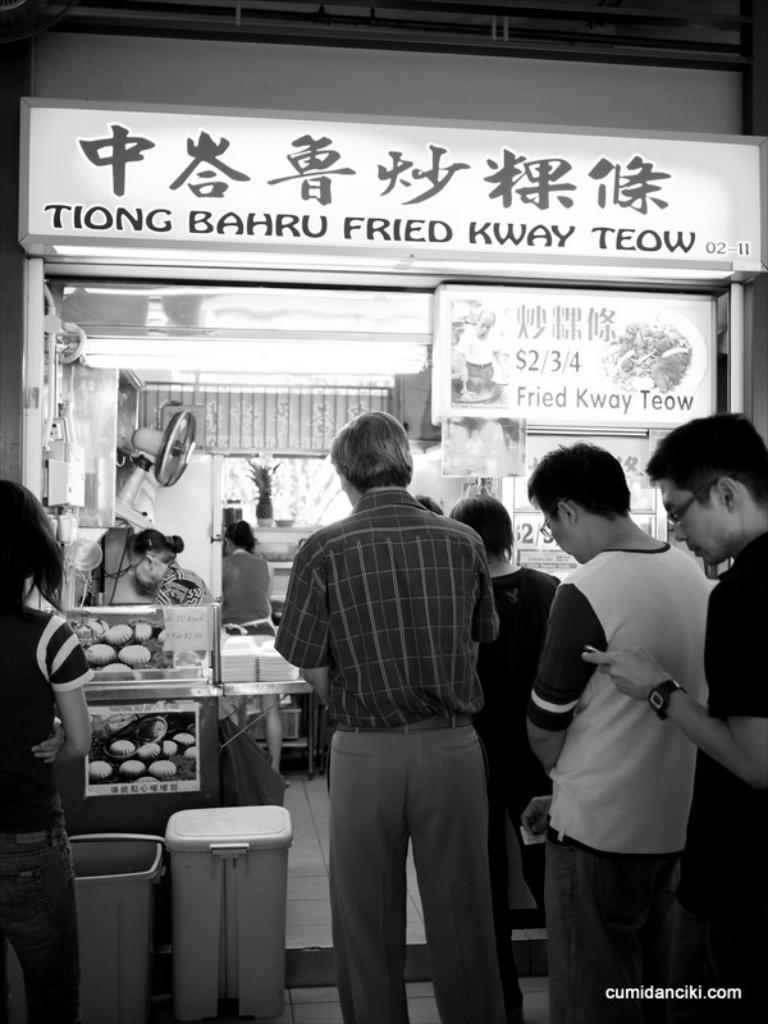<image>
Provide a brief description of the given image. A group of people stand in line at the Tiong Bahru Fried Kway Teow restaurant. 